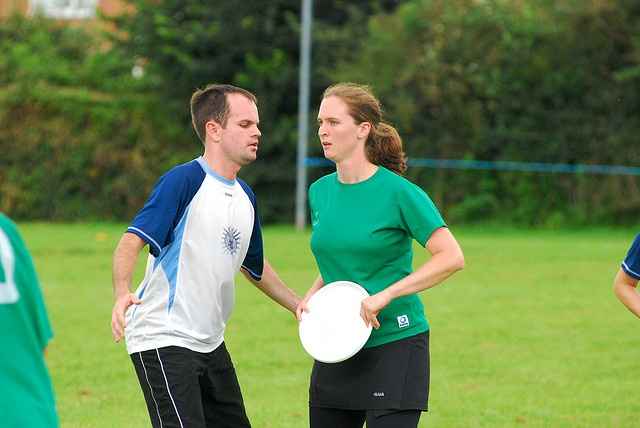Describe the objects in this image and their specific colors. I can see people in tan, lightgray, black, lightpink, and blue tones, people in tan, black, turquoise, and green tones, people in tan, turquoise, teal, lightblue, and lightgreen tones, frisbee in tan, white, pink, and salmon tones, and people in tan, navy, and brown tones in this image. 